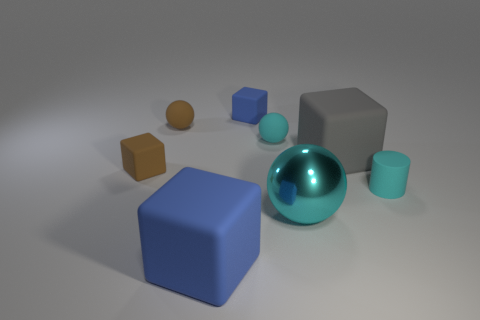What size is the metallic thing that is the same color as the small matte cylinder?
Your answer should be very brief. Large. There is a blue thing in front of the tiny cyan rubber object right of the large ball; are there any objects in front of it?
Offer a very short reply. No. There is a small brown sphere; are there any brown matte things behind it?
Offer a terse response. No. There is a big blue matte block on the left side of the large ball; what number of brown cubes are to the right of it?
Offer a very short reply. 0. Do the cyan metallic thing and the blue thing that is in front of the brown rubber sphere have the same size?
Offer a terse response. Yes. Are there any big metallic things that have the same color as the rubber cylinder?
Provide a succinct answer. Yes. What is the size of the cyan sphere that is the same material as the tiny blue block?
Keep it short and to the point. Small. Is the material of the brown ball the same as the tiny cyan ball?
Keep it short and to the point. Yes. There is a tiny ball that is left of the large matte thing in front of the large rubber object on the right side of the tiny blue rubber object; what is its color?
Ensure brevity in your answer.  Brown. What shape is the big blue matte thing?
Ensure brevity in your answer.  Cube. 